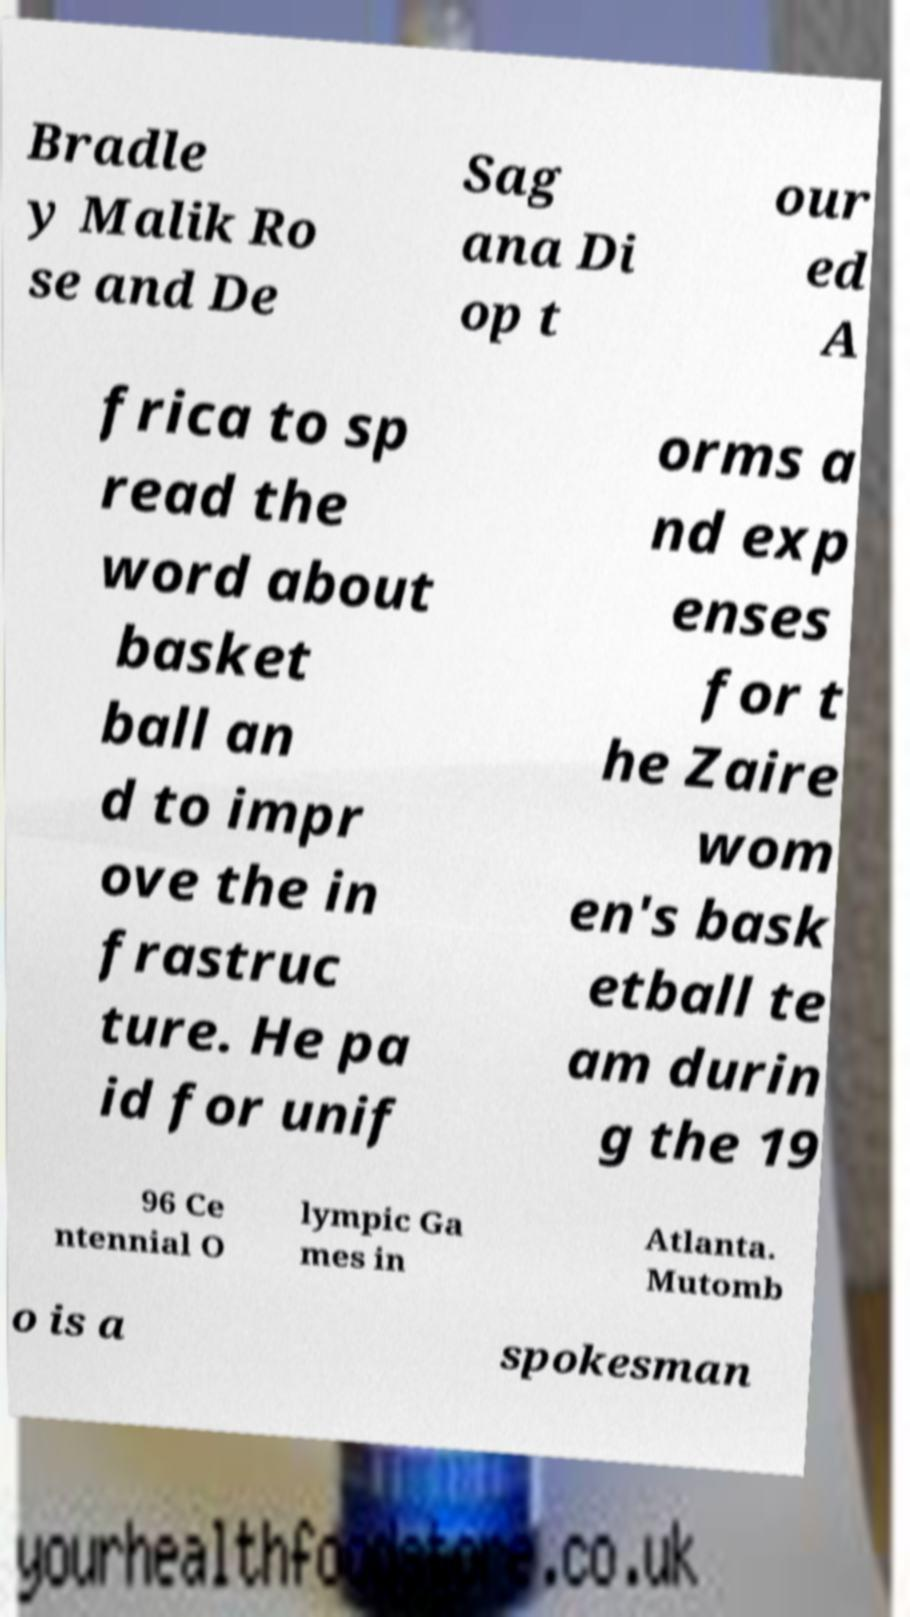Can you read and provide the text displayed in the image?This photo seems to have some interesting text. Can you extract and type it out for me? Bradle y Malik Ro se and De Sag ana Di op t our ed A frica to sp read the word about basket ball an d to impr ove the in frastruc ture. He pa id for unif orms a nd exp enses for t he Zaire wom en's bask etball te am durin g the 19 96 Ce ntennial O lympic Ga mes in Atlanta. Mutomb o is a spokesman 